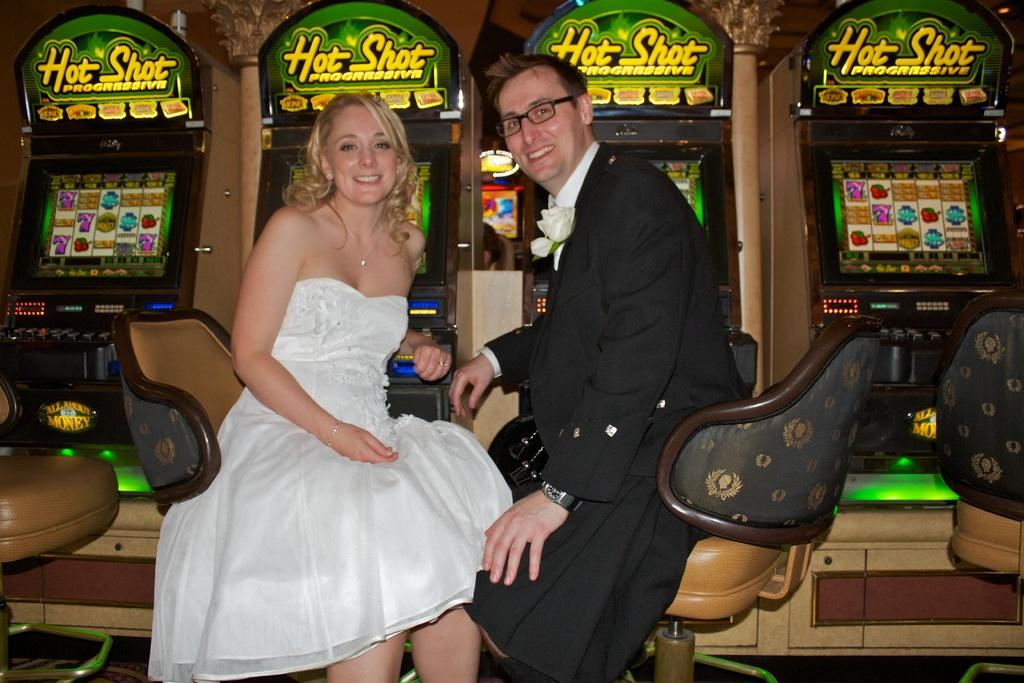Who can be seen in the image? There is a woman and a man in the image. What are the woman and man doing in the image? Both the woman and man are sitting on chairs. What can be seen in the background of the image? There are four gaming slots visible in the background. What type of trail can be seen in the image? There is no trail present in the image. 